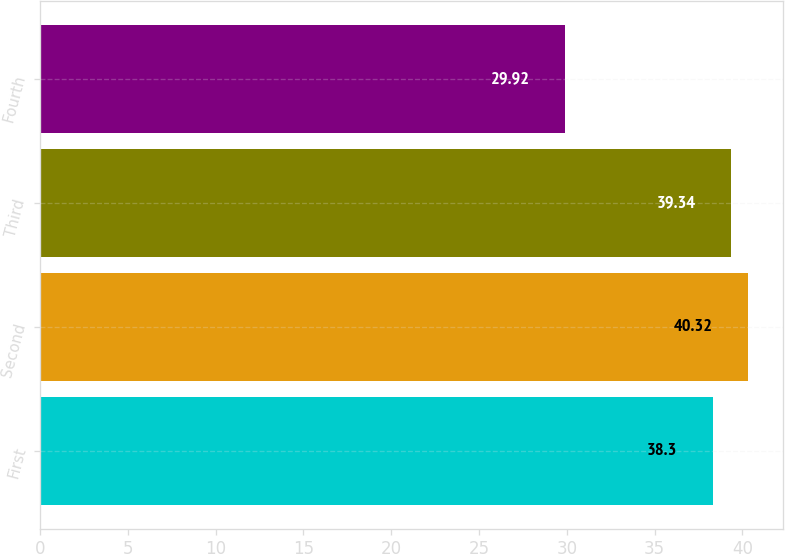<chart> <loc_0><loc_0><loc_500><loc_500><bar_chart><fcel>First<fcel>Second<fcel>Third<fcel>Fourth<nl><fcel>38.3<fcel>40.32<fcel>39.34<fcel>29.92<nl></chart> 